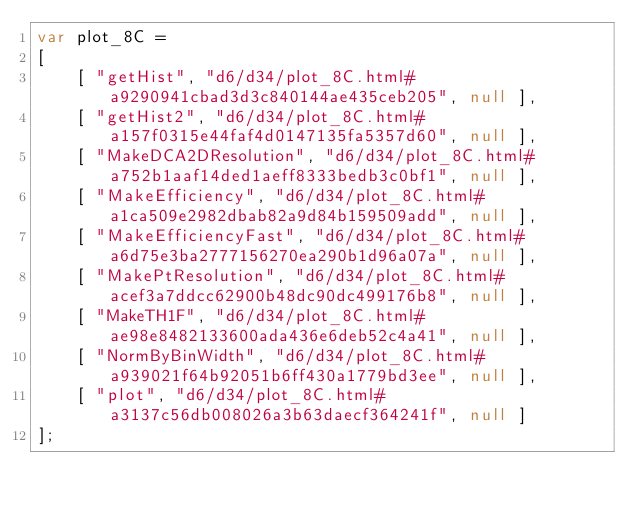<code> <loc_0><loc_0><loc_500><loc_500><_JavaScript_>var plot_8C =
[
    [ "getHist", "d6/d34/plot_8C.html#a9290941cbad3d3c840144ae435ceb205", null ],
    [ "getHist2", "d6/d34/plot_8C.html#a157f0315e44faf4d0147135fa5357d60", null ],
    [ "MakeDCA2DResolution", "d6/d34/plot_8C.html#a752b1aaf14ded1aeff8333bedb3c0bf1", null ],
    [ "MakeEfficiency", "d6/d34/plot_8C.html#a1ca509e2982dbab82a9d84b159509add", null ],
    [ "MakeEfficiencyFast", "d6/d34/plot_8C.html#a6d75e3ba2777156270ea290b1d96a07a", null ],
    [ "MakePtResolution", "d6/d34/plot_8C.html#acef3a7ddcc62900b48dc90dc499176b8", null ],
    [ "MakeTH1F", "d6/d34/plot_8C.html#ae98e8482133600ada436e6deb52c4a41", null ],
    [ "NormByBinWidth", "d6/d34/plot_8C.html#a939021f64b92051b6ff430a1779bd3ee", null ],
    [ "plot", "d6/d34/plot_8C.html#a3137c56db008026a3b63daecf364241f", null ]
];</code> 